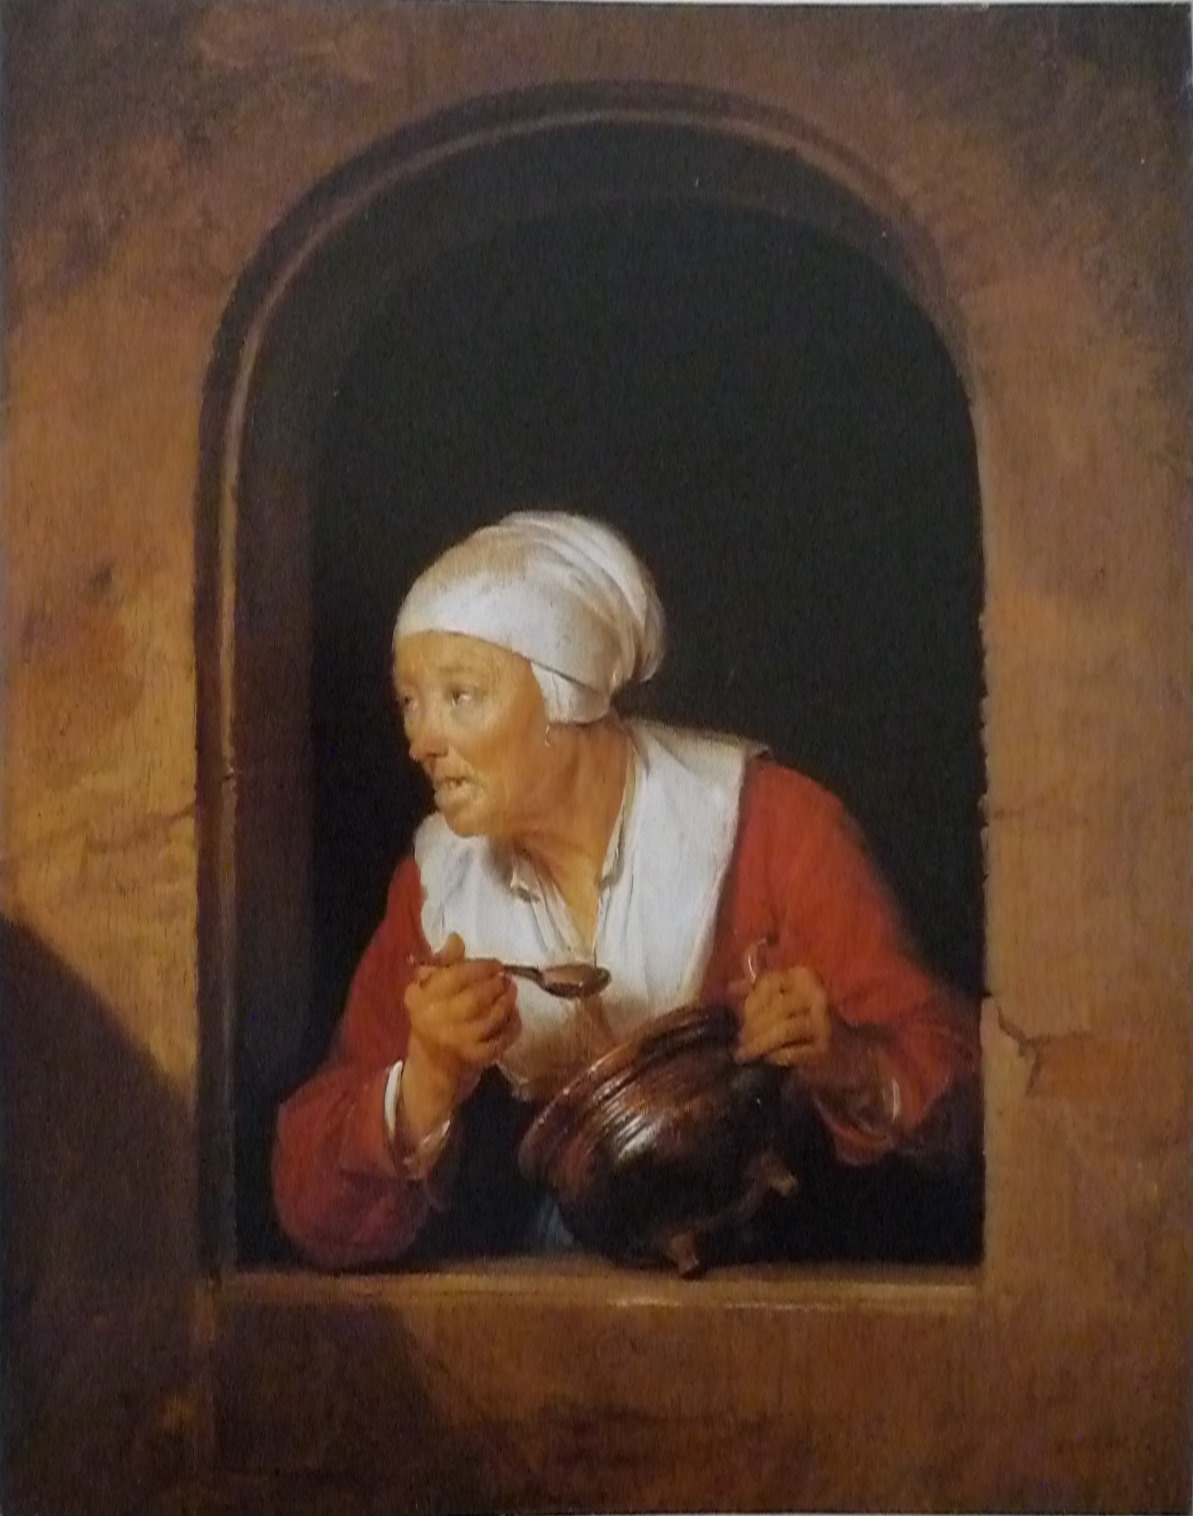Provide a brief historical analysis of the attire worn by the woman in the image. The woman in the image is dressed in clothing that is characteristic of the 17th-century working class in Europe. Her red blouse, simple yet vibrant, indicates practical attire suited for daily chores, while the white headscarf suggests modesty and adherence to the dress norms of her time. Such head coverings were commonly worn by women to maintain cleanliness and denote modesty. The use of warm, earthy colors in her clothing aligns with the Baroque period's focus on realism and the portrayal of everyday life. The garments are functional, designed for practicality and comfort, reflecting the utilitarian approach to fashion among the working class of the era. 